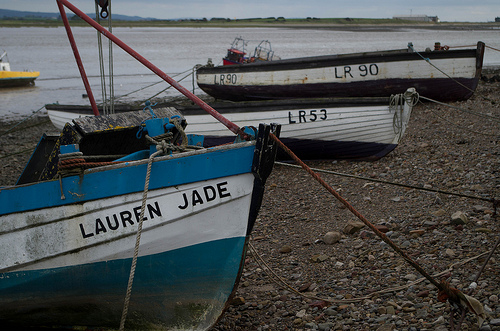How many LR's are visible? There are three boats with 'LR' visible in the image, denoting the registration number of the boats, which are commonly used for identification purposes. This suggests that we are likely looking at a scene from a location where boats are registered with 'LR' as part of their identification code. 